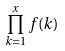<formula> <loc_0><loc_0><loc_500><loc_500>\prod _ { k = 1 } ^ { x } f ( k )</formula> 